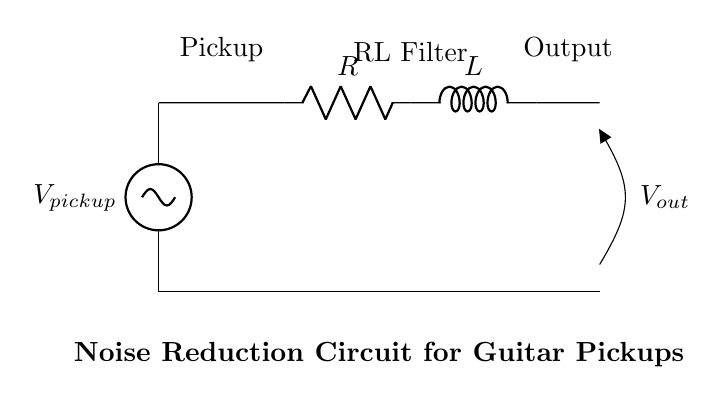What component is the first in the circuit? The first component in the circuit is the voltage source, which is labeled as V_pickup. This component provides the initial electrical energy to the circuit.
Answer: Voltage source What is the purpose of the resistor in this circuit? The resistor, labeled as R, serves to limit the current flowing through the circuit. It is a key component in controlling the overall impedance and helps reduce noise by filtering out high-frequency signals.
Answer: Current limiting What type of filter is represented in this circuit? The circuit presents an RL filter, which consists of a resistor and an inductor working together to attenuate high-frequency noise and allow low-frequency signals to pass.
Answer: RL filter What will be the output voltage label in this circuit? The output voltage can be found at the point labeled V_out, which indicates the voltage that will be measured across this point after the noise has been filtered.
Answer: V_out How many components are in the RL filter section of this circuit? The RL filter section consists of two components: one resistor (R) and one inductor (L), which work together to perform filtering.
Answer: Two components What happens to high-frequency noise signals in this circuit? High-frequency noise signals are attenuated or reduced in amplitude due to the combination of the resistor and inductor in the RL filter. This creates a smoother output signal, lowering the noise level.
Answer: Attenuated What is the effect of increasing the resistance in this noise reduction circuit? Increasing the resistance would lead to greater attenuation of high-frequency signals while potentially impacting the overall signal level and bandwidth. The circuit will filter out noise more effectively but may reduce the desired signal strength as well.
Answer: Greater attenuation 